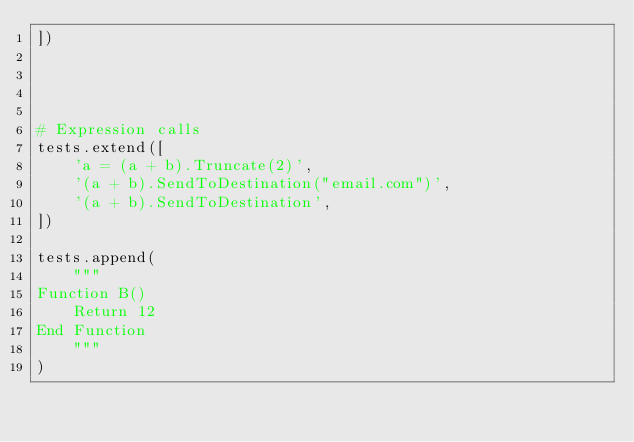Convert code to text. <code><loc_0><loc_0><loc_500><loc_500><_Python_>])




# Expression calls
tests.extend([
    'a = (a + b).Truncate(2)',
    '(a + b).SendToDestination("email.com")',
    '(a + b).SendToDestination',
])

tests.append(
    """
Function B()
    Return 12
End Function             
    """
)
</code> 